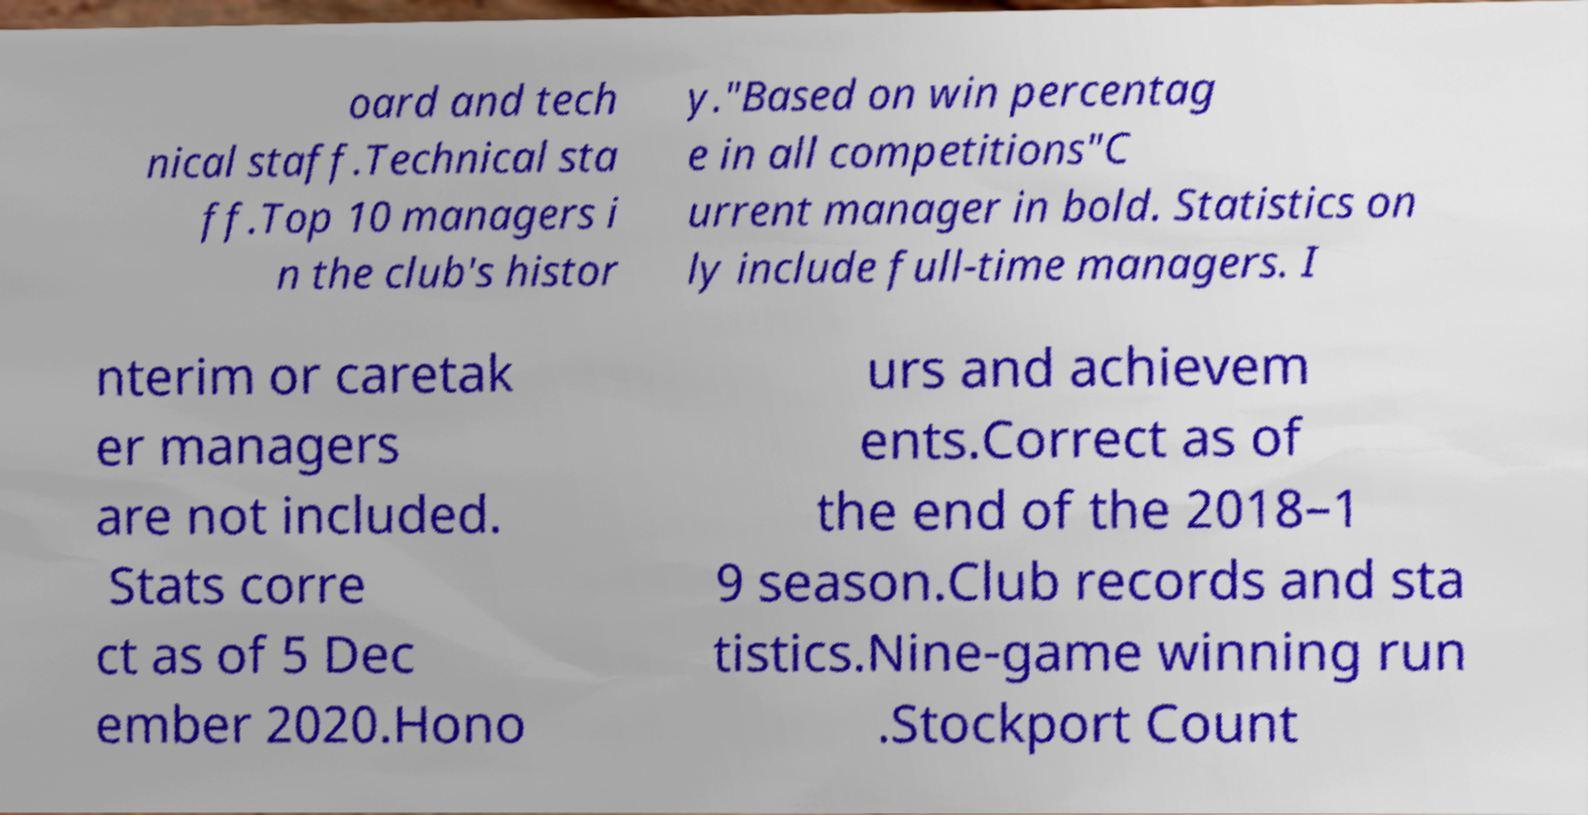Could you extract and type out the text from this image? oard and tech nical staff.Technical sta ff.Top 10 managers i n the club's histor y."Based on win percentag e in all competitions"C urrent manager in bold. Statistics on ly include full-time managers. I nterim or caretak er managers are not included. Stats corre ct as of 5 Dec ember 2020.Hono urs and achievem ents.Correct as of the end of the 2018–1 9 season.Club records and sta tistics.Nine-game winning run .Stockport Count 